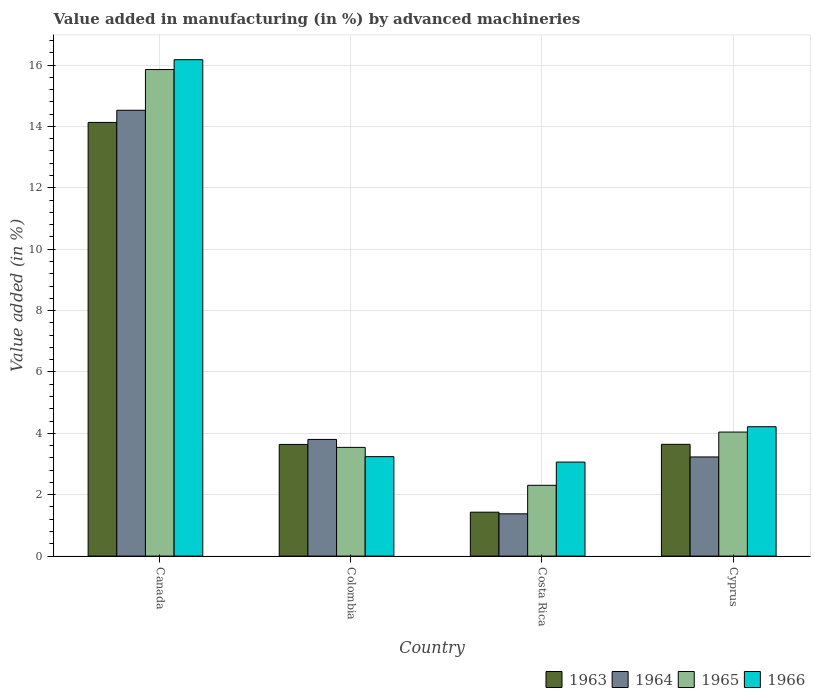How many groups of bars are there?
Your response must be concise. 4. Are the number of bars on each tick of the X-axis equal?
Give a very brief answer. Yes. How many bars are there on the 4th tick from the left?
Provide a short and direct response. 4. What is the label of the 4th group of bars from the left?
Your response must be concise. Cyprus. In how many cases, is the number of bars for a given country not equal to the number of legend labels?
Provide a succinct answer. 0. What is the percentage of value added in manufacturing by advanced machineries in 1964 in Canada?
Your response must be concise. 14.53. Across all countries, what is the maximum percentage of value added in manufacturing by advanced machineries in 1964?
Give a very brief answer. 14.53. Across all countries, what is the minimum percentage of value added in manufacturing by advanced machineries in 1966?
Make the answer very short. 3.06. In which country was the percentage of value added in manufacturing by advanced machineries in 1965 maximum?
Keep it short and to the point. Canada. In which country was the percentage of value added in manufacturing by advanced machineries in 1963 minimum?
Offer a very short reply. Costa Rica. What is the total percentage of value added in manufacturing by advanced machineries in 1963 in the graph?
Make the answer very short. 22.84. What is the difference between the percentage of value added in manufacturing by advanced machineries in 1963 in Colombia and that in Costa Rica?
Offer a terse response. 2.21. What is the difference between the percentage of value added in manufacturing by advanced machineries in 1964 in Canada and the percentage of value added in manufacturing by advanced machineries in 1963 in Colombia?
Offer a very short reply. 10.89. What is the average percentage of value added in manufacturing by advanced machineries in 1964 per country?
Your answer should be compact. 5.73. What is the difference between the percentage of value added in manufacturing by advanced machineries of/in 1963 and percentage of value added in manufacturing by advanced machineries of/in 1965 in Canada?
Give a very brief answer. -1.72. What is the ratio of the percentage of value added in manufacturing by advanced machineries in 1964 in Canada to that in Cyprus?
Your answer should be compact. 4.5. Is the percentage of value added in manufacturing by advanced machineries in 1963 in Canada less than that in Costa Rica?
Provide a succinct answer. No. Is the difference between the percentage of value added in manufacturing by advanced machineries in 1963 in Canada and Colombia greater than the difference between the percentage of value added in manufacturing by advanced machineries in 1965 in Canada and Colombia?
Provide a short and direct response. No. What is the difference between the highest and the second highest percentage of value added in manufacturing by advanced machineries in 1964?
Your answer should be very brief. -0.57. What is the difference between the highest and the lowest percentage of value added in manufacturing by advanced machineries in 1963?
Provide a short and direct response. 12.7. Is the sum of the percentage of value added in manufacturing by advanced machineries in 1963 in Colombia and Cyprus greater than the maximum percentage of value added in manufacturing by advanced machineries in 1965 across all countries?
Your response must be concise. No. What does the 3rd bar from the left in Canada represents?
Make the answer very short. 1965. Does the graph contain any zero values?
Offer a very short reply. No. Does the graph contain grids?
Provide a short and direct response. Yes. Where does the legend appear in the graph?
Your answer should be compact. Bottom right. How many legend labels are there?
Make the answer very short. 4. What is the title of the graph?
Provide a succinct answer. Value added in manufacturing (in %) by advanced machineries. What is the label or title of the X-axis?
Your response must be concise. Country. What is the label or title of the Y-axis?
Give a very brief answer. Value added (in %). What is the Value added (in %) in 1963 in Canada?
Make the answer very short. 14.13. What is the Value added (in %) in 1964 in Canada?
Provide a short and direct response. 14.53. What is the Value added (in %) in 1965 in Canada?
Your response must be concise. 15.85. What is the Value added (in %) of 1966 in Canada?
Give a very brief answer. 16.17. What is the Value added (in %) of 1963 in Colombia?
Give a very brief answer. 3.64. What is the Value added (in %) of 1964 in Colombia?
Your answer should be very brief. 3.8. What is the Value added (in %) of 1965 in Colombia?
Ensure brevity in your answer.  3.54. What is the Value added (in %) in 1966 in Colombia?
Offer a terse response. 3.24. What is the Value added (in %) in 1963 in Costa Rica?
Ensure brevity in your answer.  1.43. What is the Value added (in %) of 1964 in Costa Rica?
Give a very brief answer. 1.38. What is the Value added (in %) of 1965 in Costa Rica?
Your answer should be compact. 2.31. What is the Value added (in %) of 1966 in Costa Rica?
Offer a terse response. 3.06. What is the Value added (in %) of 1963 in Cyprus?
Make the answer very short. 3.64. What is the Value added (in %) in 1964 in Cyprus?
Your answer should be very brief. 3.23. What is the Value added (in %) in 1965 in Cyprus?
Provide a succinct answer. 4.04. What is the Value added (in %) in 1966 in Cyprus?
Ensure brevity in your answer.  4.22. Across all countries, what is the maximum Value added (in %) of 1963?
Provide a succinct answer. 14.13. Across all countries, what is the maximum Value added (in %) of 1964?
Keep it short and to the point. 14.53. Across all countries, what is the maximum Value added (in %) of 1965?
Make the answer very short. 15.85. Across all countries, what is the maximum Value added (in %) of 1966?
Give a very brief answer. 16.17. Across all countries, what is the minimum Value added (in %) in 1963?
Ensure brevity in your answer.  1.43. Across all countries, what is the minimum Value added (in %) of 1964?
Ensure brevity in your answer.  1.38. Across all countries, what is the minimum Value added (in %) in 1965?
Keep it short and to the point. 2.31. Across all countries, what is the minimum Value added (in %) in 1966?
Your response must be concise. 3.06. What is the total Value added (in %) of 1963 in the graph?
Your answer should be very brief. 22.84. What is the total Value added (in %) in 1964 in the graph?
Give a very brief answer. 22.94. What is the total Value added (in %) in 1965 in the graph?
Your answer should be compact. 25.74. What is the total Value added (in %) of 1966 in the graph?
Provide a short and direct response. 26.69. What is the difference between the Value added (in %) of 1963 in Canada and that in Colombia?
Keep it short and to the point. 10.49. What is the difference between the Value added (in %) of 1964 in Canada and that in Colombia?
Keep it short and to the point. 10.72. What is the difference between the Value added (in %) of 1965 in Canada and that in Colombia?
Your answer should be compact. 12.31. What is the difference between the Value added (in %) of 1966 in Canada and that in Colombia?
Ensure brevity in your answer.  12.93. What is the difference between the Value added (in %) in 1963 in Canada and that in Costa Rica?
Your response must be concise. 12.7. What is the difference between the Value added (in %) of 1964 in Canada and that in Costa Rica?
Provide a succinct answer. 13.15. What is the difference between the Value added (in %) in 1965 in Canada and that in Costa Rica?
Your answer should be very brief. 13.55. What is the difference between the Value added (in %) of 1966 in Canada and that in Costa Rica?
Offer a terse response. 13.11. What is the difference between the Value added (in %) in 1963 in Canada and that in Cyprus?
Keep it short and to the point. 10.49. What is the difference between the Value added (in %) of 1964 in Canada and that in Cyprus?
Your response must be concise. 11.3. What is the difference between the Value added (in %) of 1965 in Canada and that in Cyprus?
Your answer should be very brief. 11.81. What is the difference between the Value added (in %) in 1966 in Canada and that in Cyprus?
Offer a very short reply. 11.96. What is the difference between the Value added (in %) in 1963 in Colombia and that in Costa Rica?
Keep it short and to the point. 2.21. What is the difference between the Value added (in %) of 1964 in Colombia and that in Costa Rica?
Give a very brief answer. 2.42. What is the difference between the Value added (in %) of 1965 in Colombia and that in Costa Rica?
Ensure brevity in your answer.  1.24. What is the difference between the Value added (in %) of 1966 in Colombia and that in Costa Rica?
Keep it short and to the point. 0.18. What is the difference between the Value added (in %) in 1963 in Colombia and that in Cyprus?
Make the answer very short. -0. What is the difference between the Value added (in %) in 1964 in Colombia and that in Cyprus?
Offer a terse response. 0.57. What is the difference between the Value added (in %) in 1965 in Colombia and that in Cyprus?
Provide a short and direct response. -0.5. What is the difference between the Value added (in %) of 1966 in Colombia and that in Cyprus?
Provide a short and direct response. -0.97. What is the difference between the Value added (in %) in 1963 in Costa Rica and that in Cyprus?
Keep it short and to the point. -2.21. What is the difference between the Value added (in %) of 1964 in Costa Rica and that in Cyprus?
Provide a short and direct response. -1.85. What is the difference between the Value added (in %) in 1965 in Costa Rica and that in Cyprus?
Make the answer very short. -1.73. What is the difference between the Value added (in %) of 1966 in Costa Rica and that in Cyprus?
Offer a very short reply. -1.15. What is the difference between the Value added (in %) in 1963 in Canada and the Value added (in %) in 1964 in Colombia?
Provide a succinct answer. 10.33. What is the difference between the Value added (in %) of 1963 in Canada and the Value added (in %) of 1965 in Colombia?
Provide a short and direct response. 10.59. What is the difference between the Value added (in %) in 1963 in Canada and the Value added (in %) in 1966 in Colombia?
Provide a short and direct response. 10.89. What is the difference between the Value added (in %) of 1964 in Canada and the Value added (in %) of 1965 in Colombia?
Offer a terse response. 10.98. What is the difference between the Value added (in %) in 1964 in Canada and the Value added (in %) in 1966 in Colombia?
Your answer should be very brief. 11.29. What is the difference between the Value added (in %) in 1965 in Canada and the Value added (in %) in 1966 in Colombia?
Your answer should be very brief. 12.61. What is the difference between the Value added (in %) of 1963 in Canada and the Value added (in %) of 1964 in Costa Rica?
Provide a short and direct response. 12.75. What is the difference between the Value added (in %) of 1963 in Canada and the Value added (in %) of 1965 in Costa Rica?
Your response must be concise. 11.82. What is the difference between the Value added (in %) of 1963 in Canada and the Value added (in %) of 1966 in Costa Rica?
Your response must be concise. 11.07. What is the difference between the Value added (in %) in 1964 in Canada and the Value added (in %) in 1965 in Costa Rica?
Provide a succinct answer. 12.22. What is the difference between the Value added (in %) of 1964 in Canada and the Value added (in %) of 1966 in Costa Rica?
Give a very brief answer. 11.46. What is the difference between the Value added (in %) of 1965 in Canada and the Value added (in %) of 1966 in Costa Rica?
Provide a succinct answer. 12.79. What is the difference between the Value added (in %) in 1963 in Canada and the Value added (in %) in 1964 in Cyprus?
Provide a succinct answer. 10.9. What is the difference between the Value added (in %) in 1963 in Canada and the Value added (in %) in 1965 in Cyprus?
Your answer should be compact. 10.09. What is the difference between the Value added (in %) in 1963 in Canada and the Value added (in %) in 1966 in Cyprus?
Your answer should be very brief. 9.92. What is the difference between the Value added (in %) in 1964 in Canada and the Value added (in %) in 1965 in Cyprus?
Your answer should be very brief. 10.49. What is the difference between the Value added (in %) in 1964 in Canada and the Value added (in %) in 1966 in Cyprus?
Keep it short and to the point. 10.31. What is the difference between the Value added (in %) in 1965 in Canada and the Value added (in %) in 1966 in Cyprus?
Offer a very short reply. 11.64. What is the difference between the Value added (in %) of 1963 in Colombia and the Value added (in %) of 1964 in Costa Rica?
Your response must be concise. 2.26. What is the difference between the Value added (in %) in 1963 in Colombia and the Value added (in %) in 1965 in Costa Rica?
Ensure brevity in your answer.  1.33. What is the difference between the Value added (in %) in 1963 in Colombia and the Value added (in %) in 1966 in Costa Rica?
Offer a very short reply. 0.57. What is the difference between the Value added (in %) in 1964 in Colombia and the Value added (in %) in 1965 in Costa Rica?
Offer a terse response. 1.49. What is the difference between the Value added (in %) of 1964 in Colombia and the Value added (in %) of 1966 in Costa Rica?
Provide a succinct answer. 0.74. What is the difference between the Value added (in %) of 1965 in Colombia and the Value added (in %) of 1966 in Costa Rica?
Offer a very short reply. 0.48. What is the difference between the Value added (in %) of 1963 in Colombia and the Value added (in %) of 1964 in Cyprus?
Provide a short and direct response. 0.41. What is the difference between the Value added (in %) of 1963 in Colombia and the Value added (in %) of 1965 in Cyprus?
Your response must be concise. -0.4. What is the difference between the Value added (in %) of 1963 in Colombia and the Value added (in %) of 1966 in Cyprus?
Keep it short and to the point. -0.58. What is the difference between the Value added (in %) of 1964 in Colombia and the Value added (in %) of 1965 in Cyprus?
Keep it short and to the point. -0.24. What is the difference between the Value added (in %) in 1964 in Colombia and the Value added (in %) in 1966 in Cyprus?
Your answer should be very brief. -0.41. What is the difference between the Value added (in %) in 1965 in Colombia and the Value added (in %) in 1966 in Cyprus?
Your answer should be very brief. -0.67. What is the difference between the Value added (in %) of 1963 in Costa Rica and the Value added (in %) of 1964 in Cyprus?
Your answer should be very brief. -1.8. What is the difference between the Value added (in %) of 1963 in Costa Rica and the Value added (in %) of 1965 in Cyprus?
Offer a terse response. -2.61. What is the difference between the Value added (in %) of 1963 in Costa Rica and the Value added (in %) of 1966 in Cyprus?
Your answer should be very brief. -2.78. What is the difference between the Value added (in %) of 1964 in Costa Rica and the Value added (in %) of 1965 in Cyprus?
Keep it short and to the point. -2.66. What is the difference between the Value added (in %) of 1964 in Costa Rica and the Value added (in %) of 1966 in Cyprus?
Provide a short and direct response. -2.84. What is the difference between the Value added (in %) of 1965 in Costa Rica and the Value added (in %) of 1966 in Cyprus?
Your answer should be compact. -1.91. What is the average Value added (in %) of 1963 per country?
Keep it short and to the point. 5.71. What is the average Value added (in %) in 1964 per country?
Provide a succinct answer. 5.73. What is the average Value added (in %) of 1965 per country?
Offer a terse response. 6.44. What is the average Value added (in %) in 1966 per country?
Your answer should be compact. 6.67. What is the difference between the Value added (in %) of 1963 and Value added (in %) of 1964 in Canada?
Make the answer very short. -0.4. What is the difference between the Value added (in %) in 1963 and Value added (in %) in 1965 in Canada?
Your answer should be very brief. -1.72. What is the difference between the Value added (in %) of 1963 and Value added (in %) of 1966 in Canada?
Offer a terse response. -2.04. What is the difference between the Value added (in %) in 1964 and Value added (in %) in 1965 in Canada?
Keep it short and to the point. -1.33. What is the difference between the Value added (in %) of 1964 and Value added (in %) of 1966 in Canada?
Your response must be concise. -1.65. What is the difference between the Value added (in %) in 1965 and Value added (in %) in 1966 in Canada?
Your answer should be compact. -0.32. What is the difference between the Value added (in %) in 1963 and Value added (in %) in 1964 in Colombia?
Your answer should be compact. -0.16. What is the difference between the Value added (in %) in 1963 and Value added (in %) in 1965 in Colombia?
Provide a succinct answer. 0.1. What is the difference between the Value added (in %) in 1963 and Value added (in %) in 1966 in Colombia?
Your response must be concise. 0.4. What is the difference between the Value added (in %) of 1964 and Value added (in %) of 1965 in Colombia?
Your answer should be very brief. 0.26. What is the difference between the Value added (in %) of 1964 and Value added (in %) of 1966 in Colombia?
Make the answer very short. 0.56. What is the difference between the Value added (in %) of 1965 and Value added (in %) of 1966 in Colombia?
Provide a succinct answer. 0.3. What is the difference between the Value added (in %) of 1963 and Value added (in %) of 1964 in Costa Rica?
Your response must be concise. 0.05. What is the difference between the Value added (in %) in 1963 and Value added (in %) in 1965 in Costa Rica?
Provide a short and direct response. -0.88. What is the difference between the Value added (in %) in 1963 and Value added (in %) in 1966 in Costa Rica?
Your answer should be very brief. -1.63. What is the difference between the Value added (in %) of 1964 and Value added (in %) of 1965 in Costa Rica?
Ensure brevity in your answer.  -0.93. What is the difference between the Value added (in %) in 1964 and Value added (in %) in 1966 in Costa Rica?
Your answer should be compact. -1.69. What is the difference between the Value added (in %) of 1965 and Value added (in %) of 1966 in Costa Rica?
Ensure brevity in your answer.  -0.76. What is the difference between the Value added (in %) of 1963 and Value added (in %) of 1964 in Cyprus?
Offer a very short reply. 0.41. What is the difference between the Value added (in %) in 1963 and Value added (in %) in 1965 in Cyprus?
Offer a very short reply. -0.4. What is the difference between the Value added (in %) in 1963 and Value added (in %) in 1966 in Cyprus?
Your response must be concise. -0.57. What is the difference between the Value added (in %) in 1964 and Value added (in %) in 1965 in Cyprus?
Offer a very short reply. -0.81. What is the difference between the Value added (in %) of 1964 and Value added (in %) of 1966 in Cyprus?
Ensure brevity in your answer.  -0.98. What is the difference between the Value added (in %) of 1965 and Value added (in %) of 1966 in Cyprus?
Make the answer very short. -0.17. What is the ratio of the Value added (in %) in 1963 in Canada to that in Colombia?
Ensure brevity in your answer.  3.88. What is the ratio of the Value added (in %) in 1964 in Canada to that in Colombia?
Provide a succinct answer. 3.82. What is the ratio of the Value added (in %) in 1965 in Canada to that in Colombia?
Give a very brief answer. 4.48. What is the ratio of the Value added (in %) in 1966 in Canada to that in Colombia?
Provide a short and direct response. 4.99. What is the ratio of the Value added (in %) of 1963 in Canada to that in Costa Rica?
Your response must be concise. 9.87. What is the ratio of the Value added (in %) of 1964 in Canada to that in Costa Rica?
Offer a very short reply. 10.54. What is the ratio of the Value added (in %) of 1965 in Canada to that in Costa Rica?
Provide a succinct answer. 6.87. What is the ratio of the Value added (in %) in 1966 in Canada to that in Costa Rica?
Provide a short and direct response. 5.28. What is the ratio of the Value added (in %) of 1963 in Canada to that in Cyprus?
Your answer should be compact. 3.88. What is the ratio of the Value added (in %) in 1964 in Canada to that in Cyprus?
Give a very brief answer. 4.5. What is the ratio of the Value added (in %) in 1965 in Canada to that in Cyprus?
Provide a succinct answer. 3.92. What is the ratio of the Value added (in %) of 1966 in Canada to that in Cyprus?
Your answer should be compact. 3.84. What is the ratio of the Value added (in %) in 1963 in Colombia to that in Costa Rica?
Offer a terse response. 2.54. What is the ratio of the Value added (in %) of 1964 in Colombia to that in Costa Rica?
Provide a short and direct response. 2.76. What is the ratio of the Value added (in %) of 1965 in Colombia to that in Costa Rica?
Your answer should be very brief. 1.54. What is the ratio of the Value added (in %) of 1966 in Colombia to that in Costa Rica?
Make the answer very short. 1.06. What is the ratio of the Value added (in %) of 1963 in Colombia to that in Cyprus?
Provide a succinct answer. 1. What is the ratio of the Value added (in %) in 1964 in Colombia to that in Cyprus?
Give a very brief answer. 1.18. What is the ratio of the Value added (in %) in 1965 in Colombia to that in Cyprus?
Offer a terse response. 0.88. What is the ratio of the Value added (in %) in 1966 in Colombia to that in Cyprus?
Give a very brief answer. 0.77. What is the ratio of the Value added (in %) of 1963 in Costa Rica to that in Cyprus?
Offer a terse response. 0.39. What is the ratio of the Value added (in %) in 1964 in Costa Rica to that in Cyprus?
Your answer should be compact. 0.43. What is the ratio of the Value added (in %) in 1965 in Costa Rica to that in Cyprus?
Give a very brief answer. 0.57. What is the ratio of the Value added (in %) in 1966 in Costa Rica to that in Cyprus?
Ensure brevity in your answer.  0.73. What is the difference between the highest and the second highest Value added (in %) in 1963?
Provide a succinct answer. 10.49. What is the difference between the highest and the second highest Value added (in %) of 1964?
Ensure brevity in your answer.  10.72. What is the difference between the highest and the second highest Value added (in %) in 1965?
Give a very brief answer. 11.81. What is the difference between the highest and the second highest Value added (in %) in 1966?
Your answer should be compact. 11.96. What is the difference between the highest and the lowest Value added (in %) of 1963?
Offer a terse response. 12.7. What is the difference between the highest and the lowest Value added (in %) in 1964?
Give a very brief answer. 13.15. What is the difference between the highest and the lowest Value added (in %) in 1965?
Your answer should be very brief. 13.55. What is the difference between the highest and the lowest Value added (in %) of 1966?
Your answer should be very brief. 13.11. 